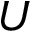Convert formula to latex. <formula><loc_0><loc_0><loc_500><loc_500>U</formula> 